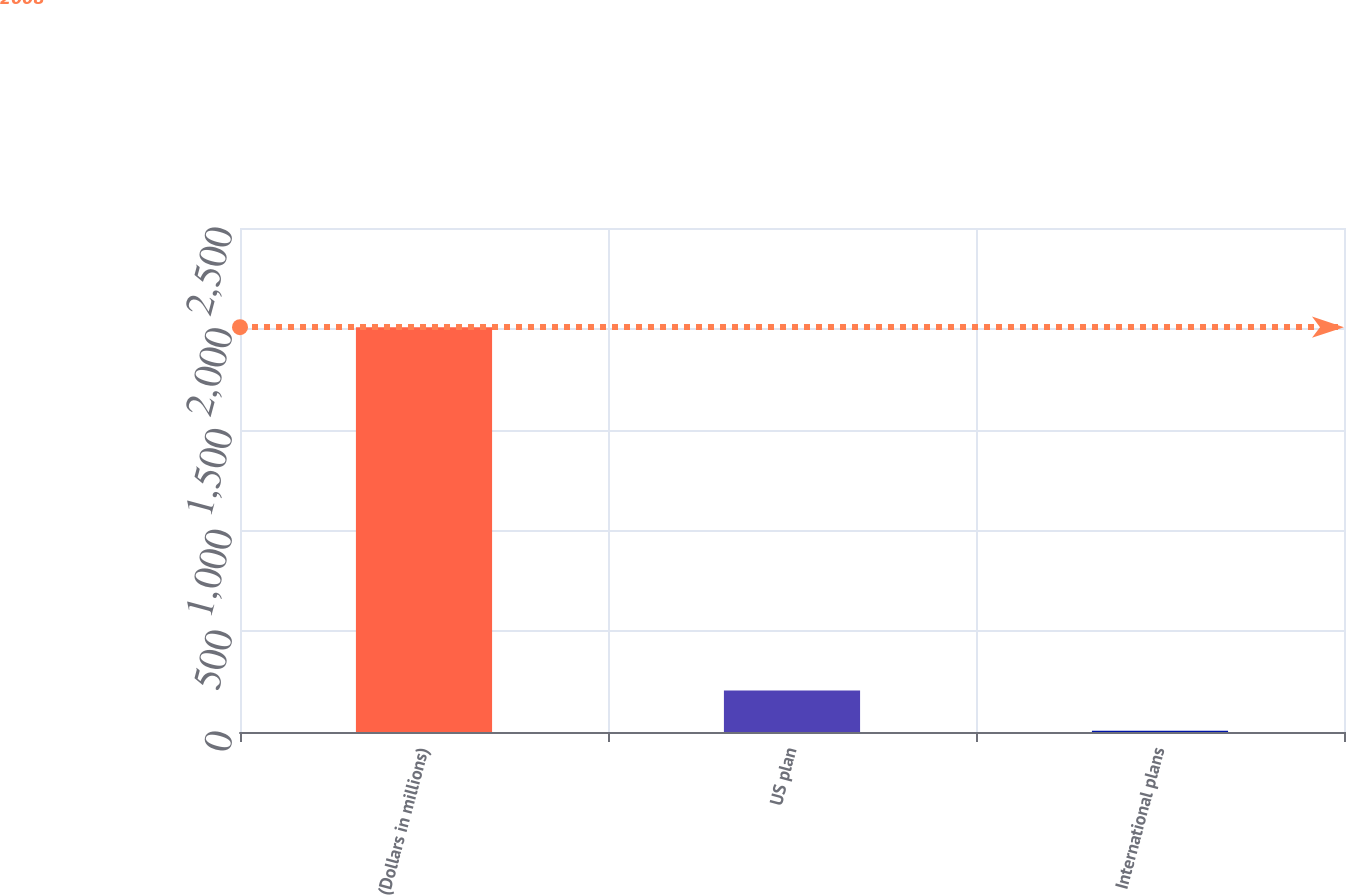Convert chart to OTSL. <chart><loc_0><loc_0><loc_500><loc_500><bar_chart><fcel>(Dollars in millions)<fcel>US plan<fcel>International plans<nl><fcel>2008<fcel>206.2<fcel>6<nl></chart> 